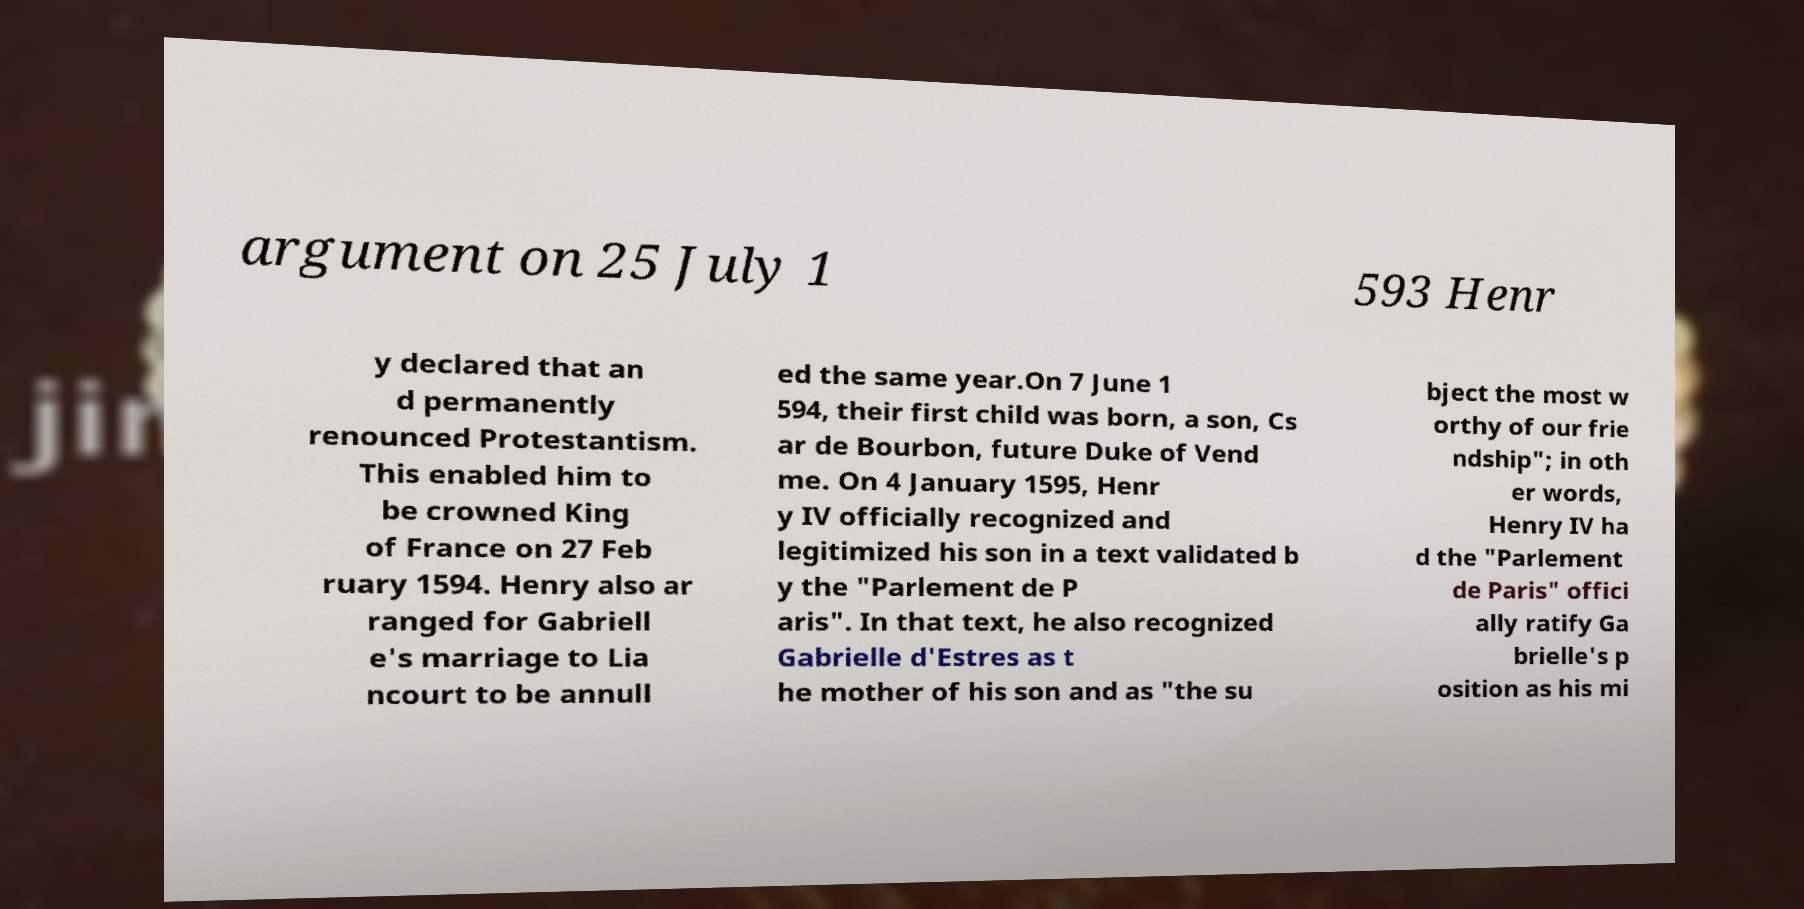For documentation purposes, I need the text within this image transcribed. Could you provide that? argument on 25 July 1 593 Henr y declared that an d permanently renounced Protestantism. This enabled him to be crowned King of France on 27 Feb ruary 1594. Henry also ar ranged for Gabriell e's marriage to Lia ncourt to be annull ed the same year.On 7 June 1 594, their first child was born, a son, Cs ar de Bourbon, future Duke of Vend me. On 4 January 1595, Henr y IV officially recognized and legitimized his son in a text validated b y the "Parlement de P aris". In that text, he also recognized Gabrielle d'Estres as t he mother of his son and as "the su bject the most w orthy of our frie ndship"; in oth er words, Henry IV ha d the "Parlement de Paris" offici ally ratify Ga brielle's p osition as his mi 